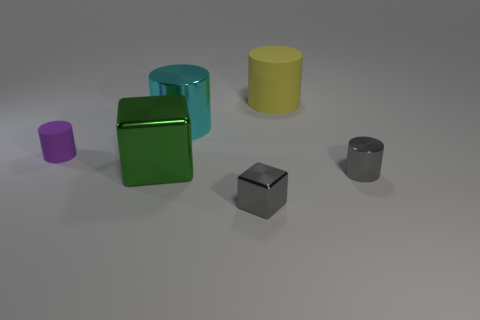Do the cyan cylinder and the purple rubber object have the same size?
Your answer should be very brief. No. What number of other things are there of the same size as the purple rubber cylinder?
Keep it short and to the point. 2. What number of things are small things that are on the right side of the tiny purple matte cylinder or objects behind the green metal thing?
Offer a terse response. 5. What is the shape of the green metal thing that is the same size as the cyan thing?
Keep it short and to the point. Cube. What size is the green thing that is made of the same material as the small gray cube?
Make the answer very short. Large. Do the big matte object and the large cyan metal thing have the same shape?
Provide a short and direct response. Yes. The shiny cube that is the same size as the purple cylinder is what color?
Give a very brief answer. Gray. There is a yellow rubber object that is the same shape as the purple object; what is its size?
Provide a short and direct response. Large. The object right of the large yellow thing has what shape?
Make the answer very short. Cylinder. Does the large green thing have the same shape as the gray shiny thing left of the tiny gray shiny cylinder?
Your response must be concise. Yes. 